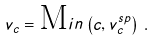<formula> <loc_0><loc_0><loc_500><loc_500>v _ { c } = { \text  Min}\left(c,v_{c}^{sp}\right) \, .</formula> 